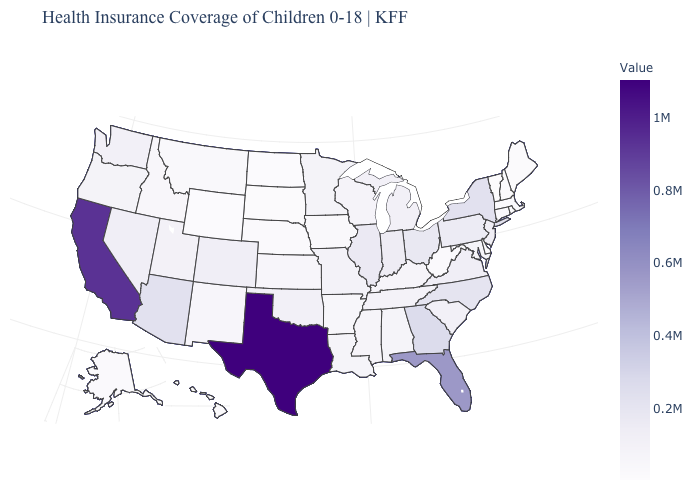Which states have the lowest value in the USA?
Be succinct. Vermont. Which states have the lowest value in the West?
Keep it brief. Wyoming. Which states have the lowest value in the Northeast?
Write a very short answer. Vermont. Among the states that border Mississippi , which have the highest value?
Keep it brief. Tennessee. Is the legend a continuous bar?
Short answer required. Yes. Which states have the lowest value in the USA?
Give a very brief answer. Vermont. Does Vermont have the lowest value in the USA?
Quick response, please. Yes. 